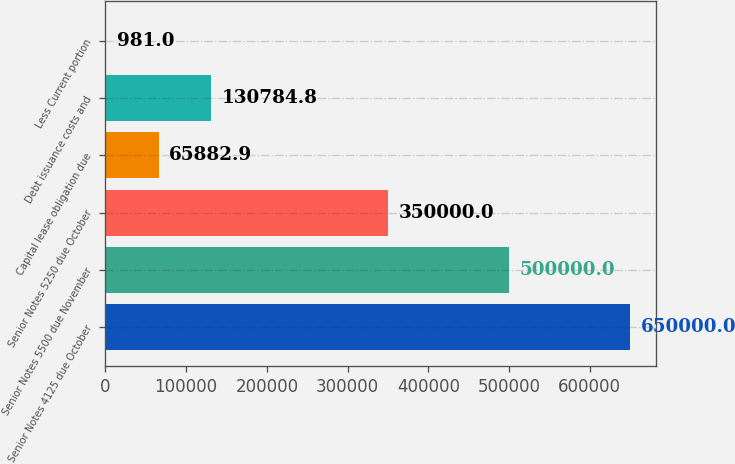Convert chart. <chart><loc_0><loc_0><loc_500><loc_500><bar_chart><fcel>Senior Notes 4125 due October<fcel>Senior Notes 5500 due November<fcel>Senior Notes 5250 due October<fcel>Capital lease obligation due<fcel>Debt issuance costs and<fcel>Less Current portion<nl><fcel>650000<fcel>500000<fcel>350000<fcel>65882.9<fcel>130785<fcel>981<nl></chart> 